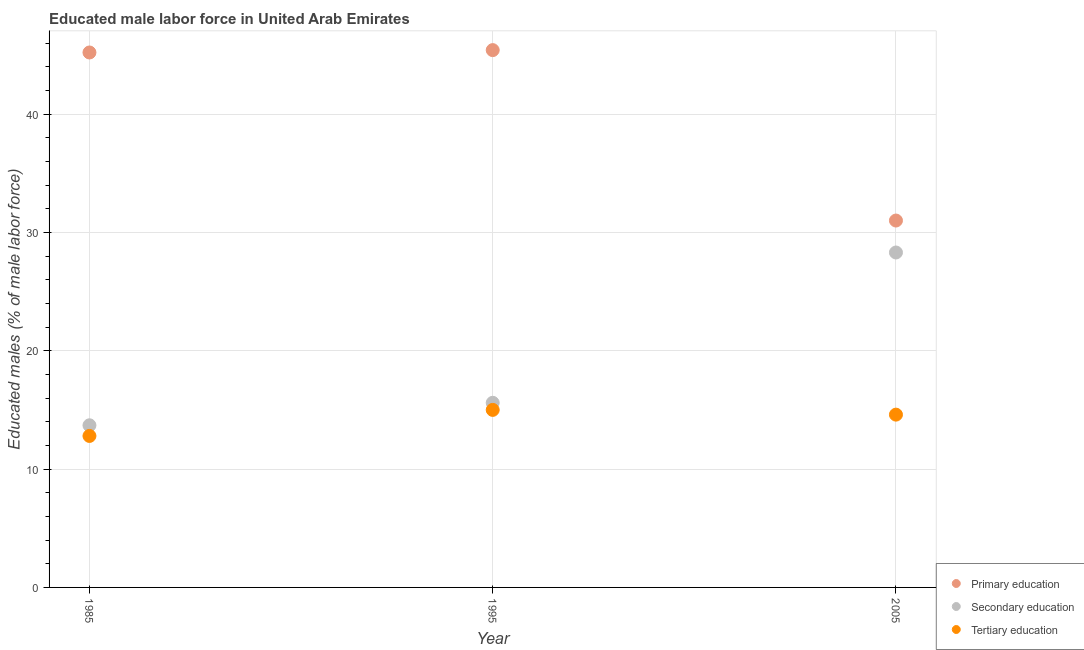Is the number of dotlines equal to the number of legend labels?
Make the answer very short. Yes. What is the percentage of male labor force who received secondary education in 1995?
Offer a terse response. 15.6. Across all years, what is the minimum percentage of male labor force who received secondary education?
Provide a short and direct response. 13.7. In which year was the percentage of male labor force who received secondary education maximum?
Offer a terse response. 2005. In which year was the percentage of male labor force who received primary education minimum?
Give a very brief answer. 2005. What is the total percentage of male labor force who received tertiary education in the graph?
Offer a terse response. 42.4. What is the difference between the percentage of male labor force who received primary education in 1985 and that in 1995?
Give a very brief answer. -0.2. What is the difference between the percentage of male labor force who received primary education in 1995 and the percentage of male labor force who received secondary education in 2005?
Provide a short and direct response. 17.1. What is the average percentage of male labor force who received secondary education per year?
Provide a short and direct response. 19.2. In the year 1995, what is the difference between the percentage of male labor force who received primary education and percentage of male labor force who received secondary education?
Your response must be concise. 29.8. What is the ratio of the percentage of male labor force who received primary education in 1985 to that in 2005?
Your response must be concise. 1.46. Is the percentage of male labor force who received tertiary education in 1985 less than that in 2005?
Make the answer very short. Yes. What is the difference between the highest and the second highest percentage of male labor force who received primary education?
Make the answer very short. 0.2. What is the difference between the highest and the lowest percentage of male labor force who received secondary education?
Ensure brevity in your answer.  14.6. In how many years, is the percentage of male labor force who received secondary education greater than the average percentage of male labor force who received secondary education taken over all years?
Provide a short and direct response. 1. Is the percentage of male labor force who received secondary education strictly greater than the percentage of male labor force who received tertiary education over the years?
Provide a short and direct response. Yes. Is the percentage of male labor force who received secondary education strictly less than the percentage of male labor force who received primary education over the years?
Your answer should be very brief. Yes. How many dotlines are there?
Ensure brevity in your answer.  3. How many years are there in the graph?
Provide a succinct answer. 3. What is the difference between two consecutive major ticks on the Y-axis?
Offer a terse response. 10. Where does the legend appear in the graph?
Make the answer very short. Bottom right. How many legend labels are there?
Offer a very short reply. 3. What is the title of the graph?
Offer a very short reply. Educated male labor force in United Arab Emirates. What is the label or title of the X-axis?
Make the answer very short. Year. What is the label or title of the Y-axis?
Your answer should be very brief. Educated males (% of male labor force). What is the Educated males (% of male labor force) of Primary education in 1985?
Provide a succinct answer. 45.2. What is the Educated males (% of male labor force) in Secondary education in 1985?
Make the answer very short. 13.7. What is the Educated males (% of male labor force) of Tertiary education in 1985?
Provide a succinct answer. 12.8. What is the Educated males (% of male labor force) in Primary education in 1995?
Your answer should be very brief. 45.4. What is the Educated males (% of male labor force) in Secondary education in 1995?
Give a very brief answer. 15.6. What is the Educated males (% of male labor force) in Secondary education in 2005?
Your response must be concise. 28.3. What is the Educated males (% of male labor force) of Tertiary education in 2005?
Offer a very short reply. 14.6. Across all years, what is the maximum Educated males (% of male labor force) in Primary education?
Offer a terse response. 45.4. Across all years, what is the maximum Educated males (% of male labor force) of Secondary education?
Provide a short and direct response. 28.3. Across all years, what is the minimum Educated males (% of male labor force) in Primary education?
Offer a terse response. 31. Across all years, what is the minimum Educated males (% of male labor force) of Secondary education?
Keep it short and to the point. 13.7. Across all years, what is the minimum Educated males (% of male labor force) of Tertiary education?
Give a very brief answer. 12.8. What is the total Educated males (% of male labor force) in Primary education in the graph?
Your response must be concise. 121.6. What is the total Educated males (% of male labor force) of Secondary education in the graph?
Offer a very short reply. 57.6. What is the total Educated males (% of male labor force) in Tertiary education in the graph?
Make the answer very short. 42.4. What is the difference between the Educated males (% of male labor force) in Secondary education in 1985 and that in 1995?
Your response must be concise. -1.9. What is the difference between the Educated males (% of male labor force) in Primary education in 1985 and that in 2005?
Provide a short and direct response. 14.2. What is the difference between the Educated males (% of male labor force) in Secondary education in 1985 and that in 2005?
Keep it short and to the point. -14.6. What is the difference between the Educated males (% of male labor force) of Primary education in 1995 and that in 2005?
Provide a succinct answer. 14.4. What is the difference between the Educated males (% of male labor force) of Primary education in 1985 and the Educated males (% of male labor force) of Secondary education in 1995?
Offer a terse response. 29.6. What is the difference between the Educated males (% of male labor force) in Primary education in 1985 and the Educated males (% of male labor force) in Tertiary education in 1995?
Provide a succinct answer. 30.2. What is the difference between the Educated males (% of male labor force) of Secondary education in 1985 and the Educated males (% of male labor force) of Tertiary education in 1995?
Offer a terse response. -1.3. What is the difference between the Educated males (% of male labor force) of Primary education in 1985 and the Educated males (% of male labor force) of Tertiary education in 2005?
Your answer should be very brief. 30.6. What is the difference between the Educated males (% of male labor force) in Secondary education in 1985 and the Educated males (% of male labor force) in Tertiary education in 2005?
Provide a short and direct response. -0.9. What is the difference between the Educated males (% of male labor force) of Primary education in 1995 and the Educated males (% of male labor force) of Tertiary education in 2005?
Offer a terse response. 30.8. What is the average Educated males (% of male labor force) in Primary education per year?
Provide a short and direct response. 40.53. What is the average Educated males (% of male labor force) of Tertiary education per year?
Provide a short and direct response. 14.13. In the year 1985, what is the difference between the Educated males (% of male labor force) of Primary education and Educated males (% of male labor force) of Secondary education?
Offer a very short reply. 31.5. In the year 1985, what is the difference between the Educated males (% of male labor force) in Primary education and Educated males (% of male labor force) in Tertiary education?
Provide a short and direct response. 32.4. In the year 1995, what is the difference between the Educated males (% of male labor force) of Primary education and Educated males (% of male labor force) of Secondary education?
Your response must be concise. 29.8. In the year 1995, what is the difference between the Educated males (% of male labor force) in Primary education and Educated males (% of male labor force) in Tertiary education?
Ensure brevity in your answer.  30.4. In the year 1995, what is the difference between the Educated males (% of male labor force) of Secondary education and Educated males (% of male labor force) of Tertiary education?
Offer a terse response. 0.6. In the year 2005, what is the difference between the Educated males (% of male labor force) of Primary education and Educated males (% of male labor force) of Secondary education?
Provide a succinct answer. 2.7. In the year 2005, what is the difference between the Educated males (% of male labor force) of Primary education and Educated males (% of male labor force) of Tertiary education?
Your answer should be compact. 16.4. What is the ratio of the Educated males (% of male labor force) in Secondary education in 1985 to that in 1995?
Your answer should be compact. 0.88. What is the ratio of the Educated males (% of male labor force) in Tertiary education in 1985 to that in 1995?
Offer a very short reply. 0.85. What is the ratio of the Educated males (% of male labor force) of Primary education in 1985 to that in 2005?
Your answer should be compact. 1.46. What is the ratio of the Educated males (% of male labor force) of Secondary education in 1985 to that in 2005?
Your response must be concise. 0.48. What is the ratio of the Educated males (% of male labor force) of Tertiary education in 1985 to that in 2005?
Provide a succinct answer. 0.88. What is the ratio of the Educated males (% of male labor force) in Primary education in 1995 to that in 2005?
Keep it short and to the point. 1.46. What is the ratio of the Educated males (% of male labor force) in Secondary education in 1995 to that in 2005?
Offer a terse response. 0.55. What is the ratio of the Educated males (% of male labor force) in Tertiary education in 1995 to that in 2005?
Provide a short and direct response. 1.03. What is the difference between the highest and the second highest Educated males (% of male labor force) in Tertiary education?
Offer a very short reply. 0.4. What is the difference between the highest and the lowest Educated males (% of male labor force) in Primary education?
Give a very brief answer. 14.4. What is the difference between the highest and the lowest Educated males (% of male labor force) of Secondary education?
Offer a very short reply. 14.6. 